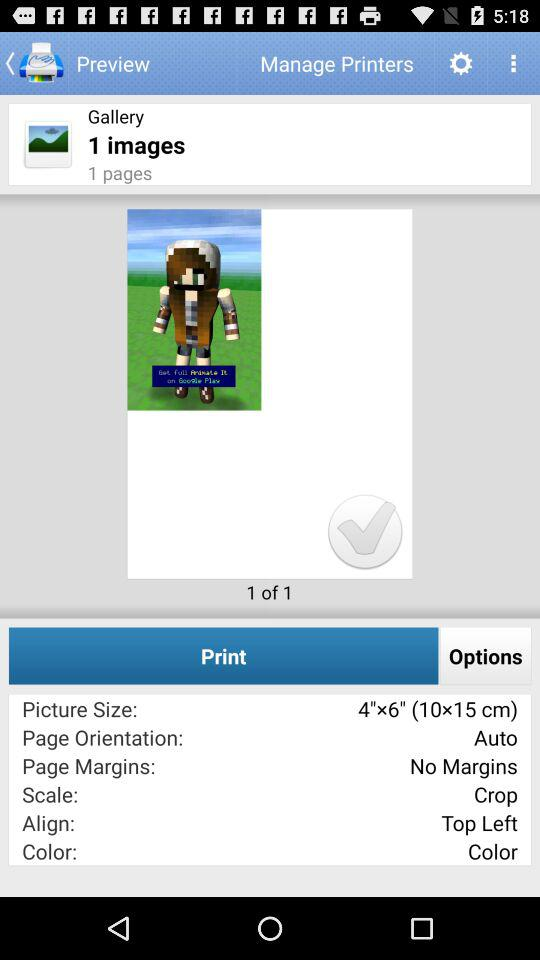What is the page margin? There are no margins. 